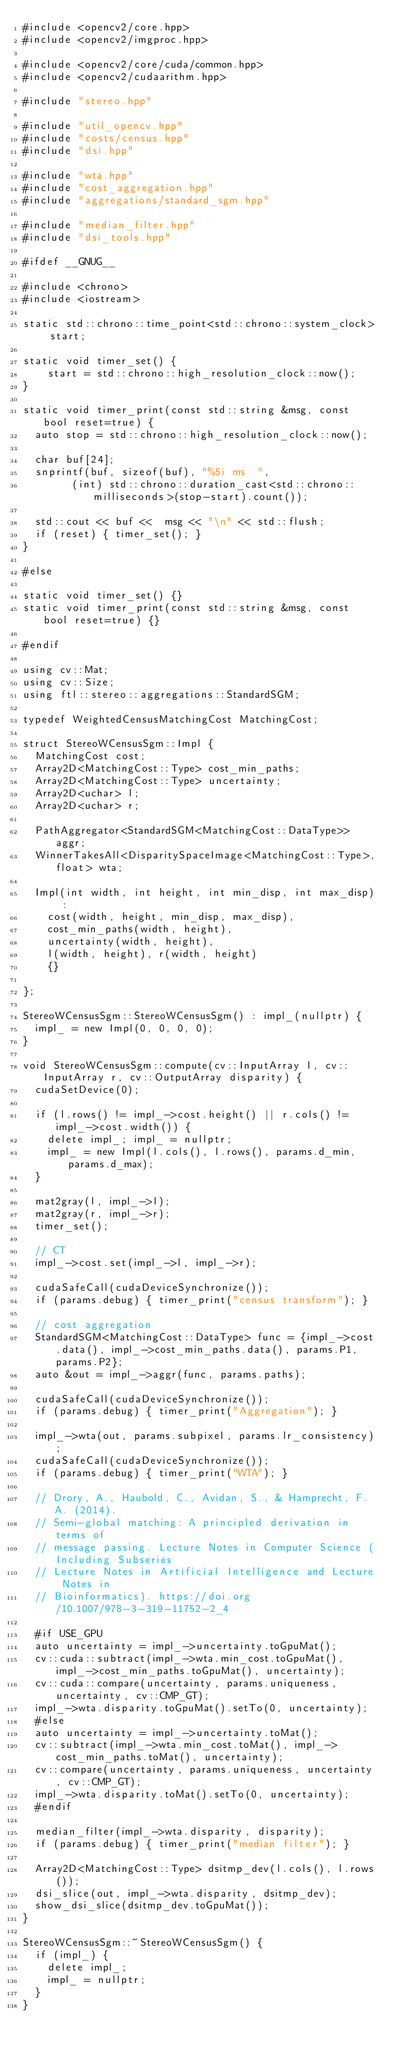<code> <loc_0><loc_0><loc_500><loc_500><_Cuda_>#include <opencv2/core.hpp>
#include <opencv2/imgproc.hpp>

#include <opencv2/core/cuda/common.hpp>
#include <opencv2/cudaarithm.hpp>

#include "stereo.hpp"

#include "util_opencv.hpp"
#include "costs/census.hpp"
#include "dsi.hpp"

#include "wta.hpp"
#include "cost_aggregation.hpp"
#include "aggregations/standard_sgm.hpp"

#include "median_filter.hpp"
#include "dsi_tools.hpp"

#ifdef __GNUG__

#include <chrono>
#include <iostream>

static std::chrono::time_point<std::chrono::system_clock> start;

static void timer_set() {
		start = std::chrono::high_resolution_clock::now();
}

static void timer_print(const std::string &msg, const bool reset=true) {
	auto stop = std::chrono::high_resolution_clock::now();

	char buf[24];
	snprintf(buf, sizeof(buf), "%5i ms  ",
				(int) std::chrono::duration_cast<std::chrono::milliseconds>(stop-start).count());

	std::cout << buf <<  msg << "\n" << std::flush;
	if (reset) { timer_set(); }
}

#else

static void timer_set() {}
static void timer_print(const std::string &msg, const bool reset=true) {}

#endif

using cv::Mat;
using cv::Size;
using ftl::stereo::aggregations::StandardSGM;

typedef WeightedCensusMatchingCost MatchingCost;

struct StereoWCensusSgm::Impl {
	MatchingCost cost;
	Array2D<MatchingCost::Type> cost_min_paths;
	Array2D<MatchingCost::Type> uncertainty;
	Array2D<uchar> l;
	Array2D<uchar> r;

	PathAggregator<StandardSGM<MatchingCost::DataType>> aggr;
	WinnerTakesAll<DisparitySpaceImage<MatchingCost::Type>,float> wta;

	Impl(int width, int height, int min_disp, int max_disp) :
		cost(width, height, min_disp, max_disp),
		cost_min_paths(width, height),
		uncertainty(width, height),
		l(width, height), r(width, height)
		{}

};

StereoWCensusSgm::StereoWCensusSgm() : impl_(nullptr) {
	impl_ = new Impl(0, 0, 0, 0);
}

void StereoWCensusSgm::compute(cv::InputArray l, cv::InputArray r, cv::OutputArray disparity) {
	cudaSetDevice(0);

	if (l.rows() != impl_->cost.height() || r.cols() != impl_->cost.width()) {
		delete impl_; impl_ = nullptr;
		impl_ = new Impl(l.cols(), l.rows(), params.d_min, params.d_max);
	}

	mat2gray(l, impl_->l);
	mat2gray(r, impl_->r);
	timer_set();

	// CT
	impl_->cost.set(impl_->l, impl_->r);

	cudaSafeCall(cudaDeviceSynchronize());
	if (params.debug) { timer_print("census transform"); }

	// cost aggregation
	StandardSGM<MatchingCost::DataType> func = {impl_->cost.data(), impl_->cost_min_paths.data(), params.P1, params.P2};
	auto &out = impl_->aggr(func, params.paths);

	cudaSafeCall(cudaDeviceSynchronize());
	if (params.debug) { timer_print("Aggregation"); }

	impl_->wta(out, params.subpixel, params.lr_consistency);
	cudaSafeCall(cudaDeviceSynchronize());
	if (params.debug) { timer_print("WTA"); }

	// Drory, A., Haubold, C., Avidan, S., & Hamprecht, F. A. (2014).
	// Semi-global matching: A principled derivation in terms of
	// message passing. Lecture Notes in Computer Science (Including Subseries
	// Lecture Notes in Artificial Intelligence and Lecture Notes in
	// Bioinformatics). https://doi.org/10.1007/978-3-319-11752-2_4

	#if USE_GPU
	auto uncertainty = impl_->uncertainty.toGpuMat();
	cv::cuda::subtract(impl_->wta.min_cost.toGpuMat(), impl_->cost_min_paths.toGpuMat(), uncertainty);
	cv::cuda::compare(uncertainty, params.uniqueness, uncertainty, cv::CMP_GT);
	impl_->wta.disparity.toGpuMat().setTo(0, uncertainty);
	#else
	auto uncertainty = impl_->uncertainty.toMat();
	cv::subtract(impl_->wta.min_cost.toMat(), impl_->cost_min_paths.toMat(), uncertainty);
	cv::compare(uncertainty, params.uniqueness, uncertainty, cv::CMP_GT);
	impl_->wta.disparity.toMat().setTo(0, uncertainty);
	#endif

	median_filter(impl_->wta.disparity, disparity);
	if (params.debug) { timer_print("median filter"); }

	Array2D<MatchingCost::Type> dsitmp_dev(l.cols(), l.rows());
	dsi_slice(out, impl_->wta.disparity, dsitmp_dev);
	show_dsi_slice(dsitmp_dev.toGpuMat());
}

StereoWCensusSgm::~StereoWCensusSgm() {
	if (impl_) {
		delete impl_;
		impl_ = nullptr;
	}
}
</code> 